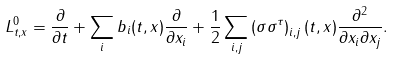Convert formula to latex. <formula><loc_0><loc_0><loc_500><loc_500>L _ { t , x } ^ { 0 } = \frac { \partial } { \partial t } + \sum _ { i } b _ { i } ( t , x ) \frac { \partial } { \partial x _ { i } } + \frac { 1 } { 2 } \sum _ { i , j } \left ( \sigma \sigma ^ { \tau } \right ) _ { i , j } ( t , x ) \frac { \partial ^ { 2 } } { \partial x _ { i } \partial x _ { j } } .</formula> 